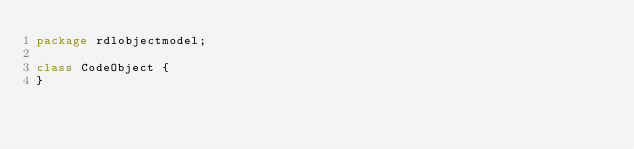Convert code to text. <code><loc_0><loc_0><loc_500><loc_500><_Haxe_>package rdlobjectmodel;

class CodeObject {
}
</code> 